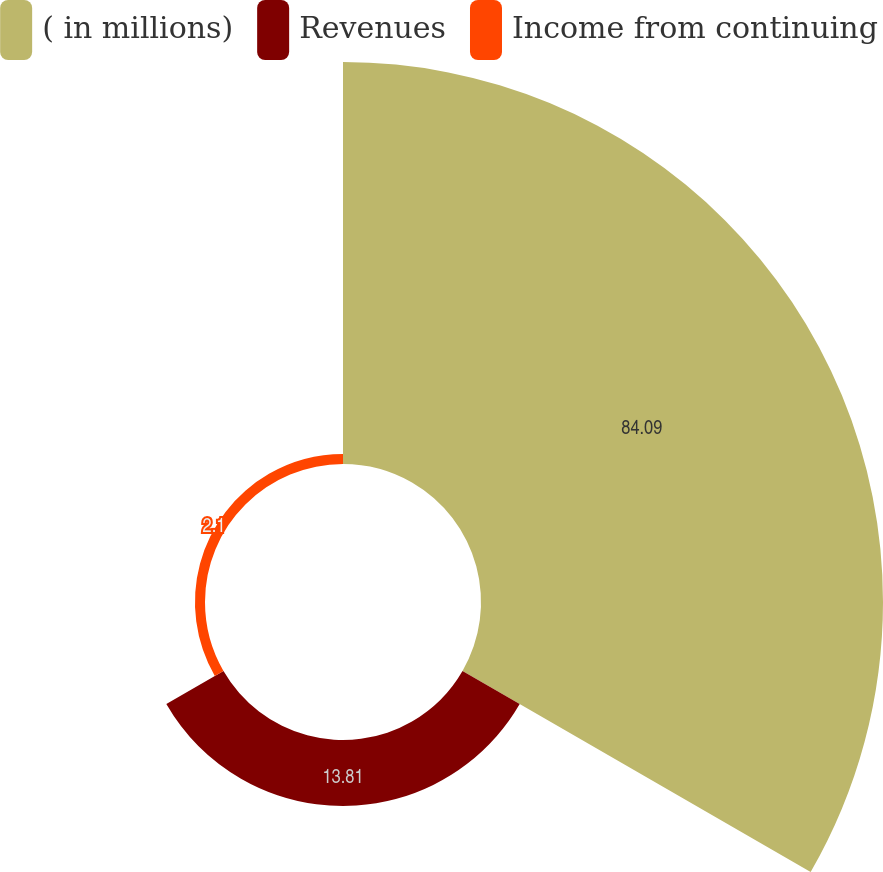<chart> <loc_0><loc_0><loc_500><loc_500><pie_chart><fcel>( in millions)<fcel>Revenues<fcel>Income from continuing<nl><fcel>84.1%<fcel>13.81%<fcel>2.1%<nl></chart> 